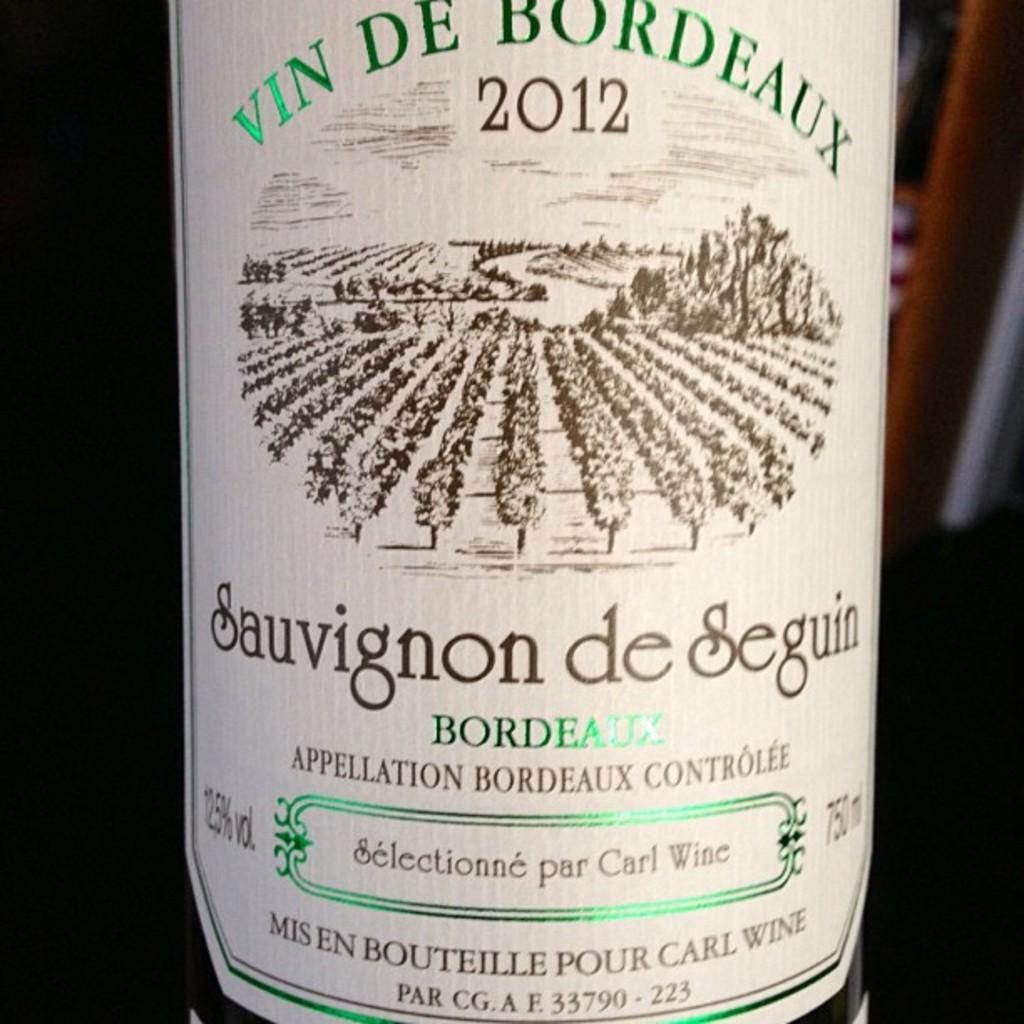Provide a one-sentence caption for the provided image. A wine label that is off white and has green and brown letters and says 2012 at the top. 